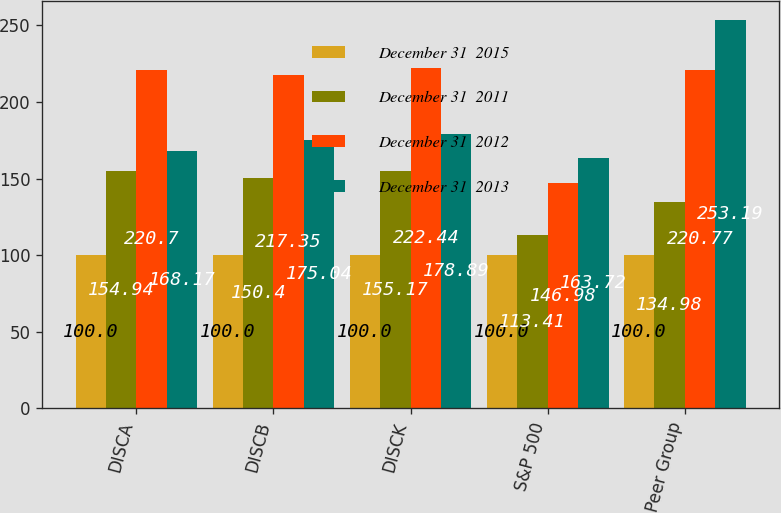Convert chart to OTSL. <chart><loc_0><loc_0><loc_500><loc_500><stacked_bar_chart><ecel><fcel>DISCA<fcel>DISCB<fcel>DISCK<fcel>S&P 500<fcel>Peer Group<nl><fcel>December 31  2015<fcel>100<fcel>100<fcel>100<fcel>100<fcel>100<nl><fcel>December 31  2011<fcel>154.94<fcel>150.4<fcel>155.17<fcel>113.41<fcel>134.98<nl><fcel>December 31  2012<fcel>220.7<fcel>217.35<fcel>222.44<fcel>146.98<fcel>220.77<nl><fcel>December 31  2013<fcel>168.17<fcel>175.04<fcel>178.89<fcel>163.72<fcel>253.19<nl></chart> 